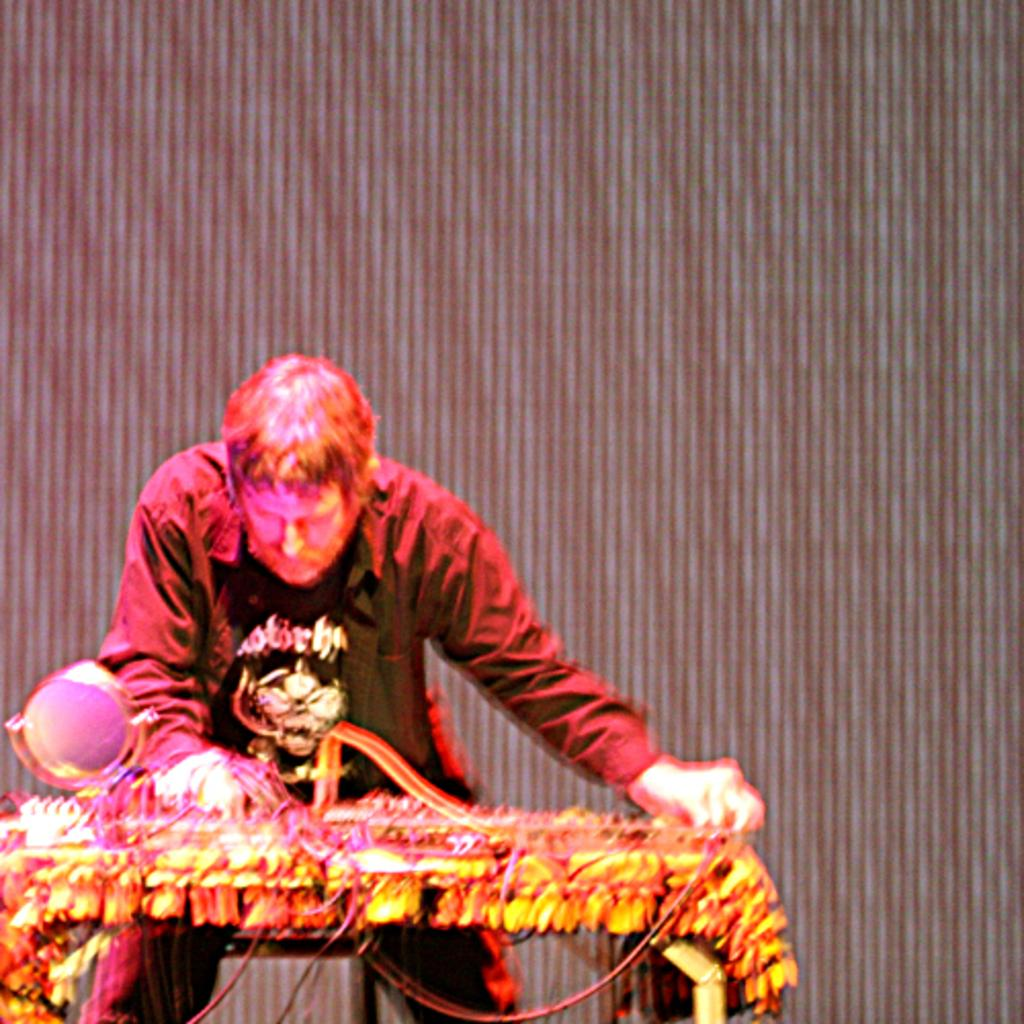Who or what is present in the image? There is a person in the image. What is the person interacting with in the image? There is a table in the image, and the person may be interacting with objects on the table. Can you describe the setting of the image? There is a curtain in the background of the image, which suggests an indoor setting. What objects can be seen on the table? The facts do not specify the objects on the table, so we cannot provide a definitive answer. What hobbies does the person in the image enjoy? The image does not provide any information about the person's hobbies, so we cannot answer this question definitively. 